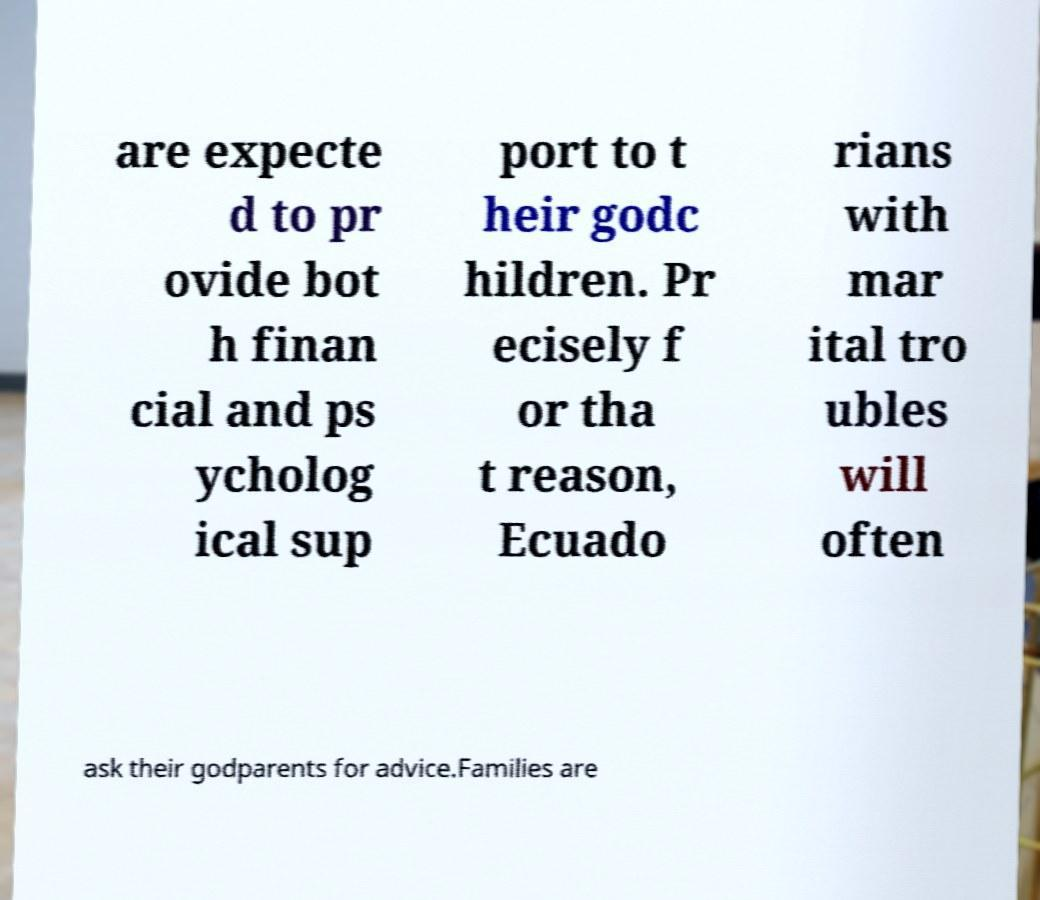For documentation purposes, I need the text within this image transcribed. Could you provide that? are expecte d to pr ovide bot h finan cial and ps ycholog ical sup port to t heir godc hildren. Pr ecisely f or tha t reason, Ecuado rians with mar ital tro ubles will often ask their godparents for advice.Families are 